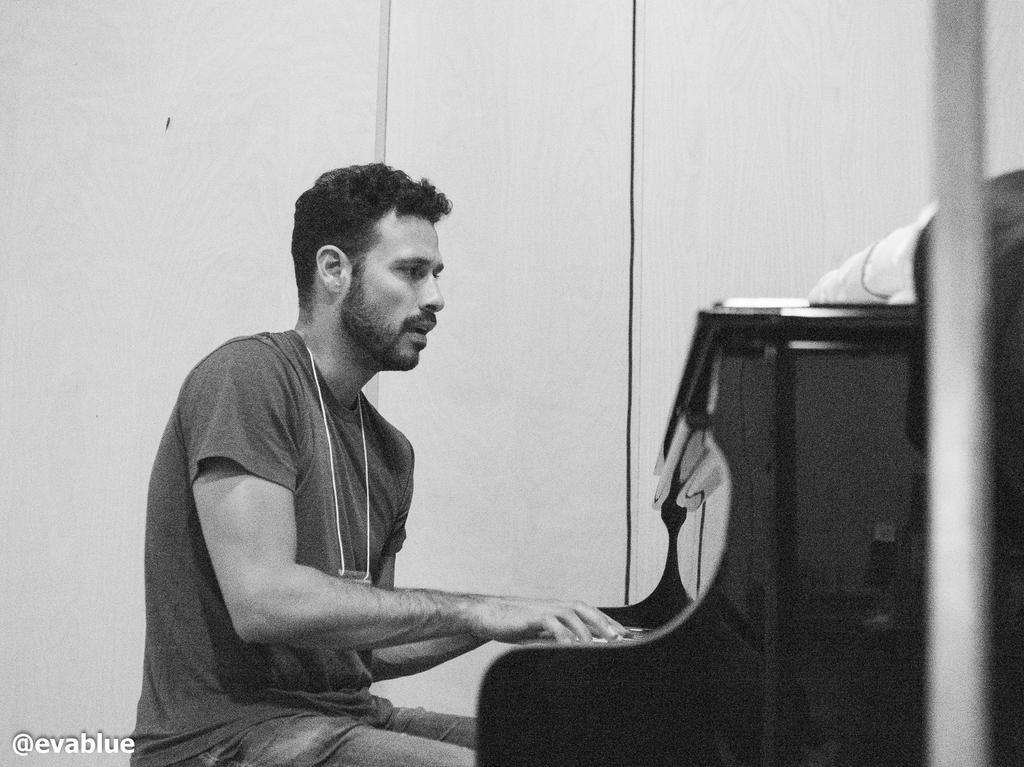What is the man in the image doing? The man is playing the piano. What is the man wearing in the image? The man is wearing a t-shirt. What can be seen in the background of the image? There is a wall in the background of the image. Can you see any roses in the image? There are no roses present in the image. Is there a crib visible in the image? There is no crib present in the image. 